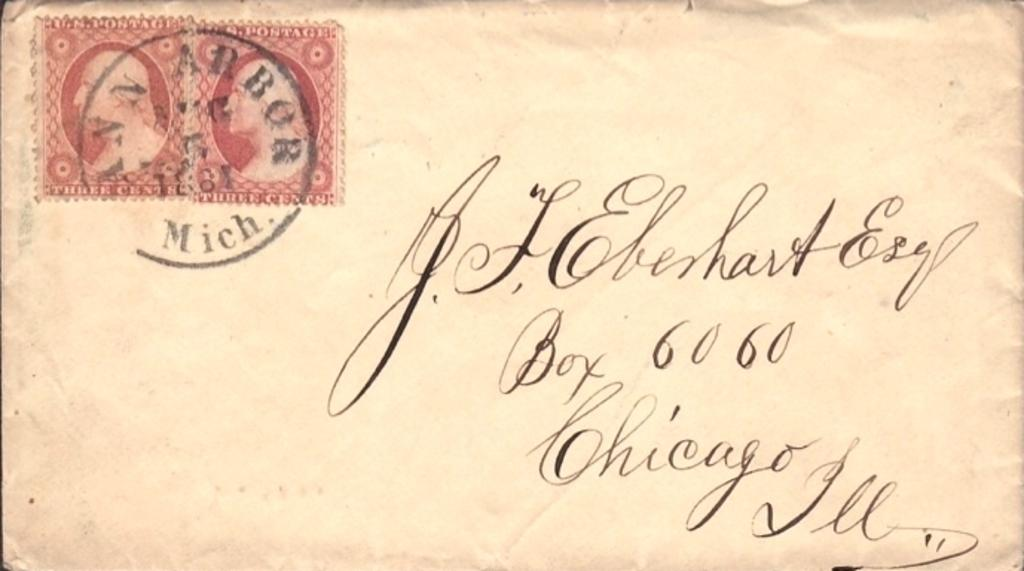<image>
Offer a succinct explanation of the picture presented. Old letter with cursive writing that is from Chicago. 